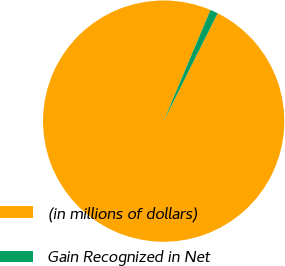Convert chart to OTSL. <chart><loc_0><loc_0><loc_500><loc_500><pie_chart><fcel>(in millions of dollars)<fcel>Gain Recognized in Net<nl><fcel>98.96%<fcel>1.04%<nl></chart> 